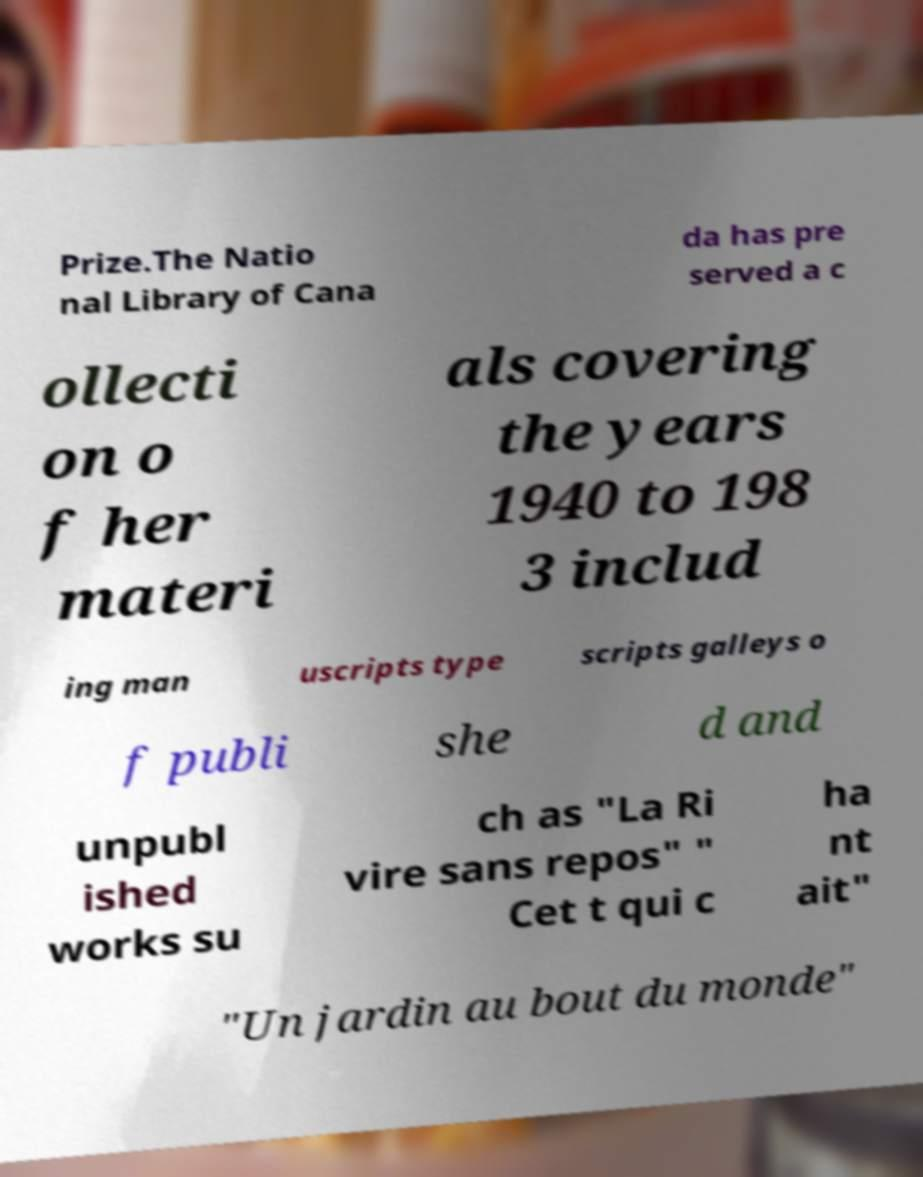Can you read and provide the text displayed in the image?This photo seems to have some interesting text. Can you extract and type it out for me? Prize.The Natio nal Library of Cana da has pre served a c ollecti on o f her materi als covering the years 1940 to 198 3 includ ing man uscripts type scripts galleys o f publi she d and unpubl ished works su ch as "La Ri vire sans repos" " Cet t qui c ha nt ait" "Un jardin au bout du monde" 